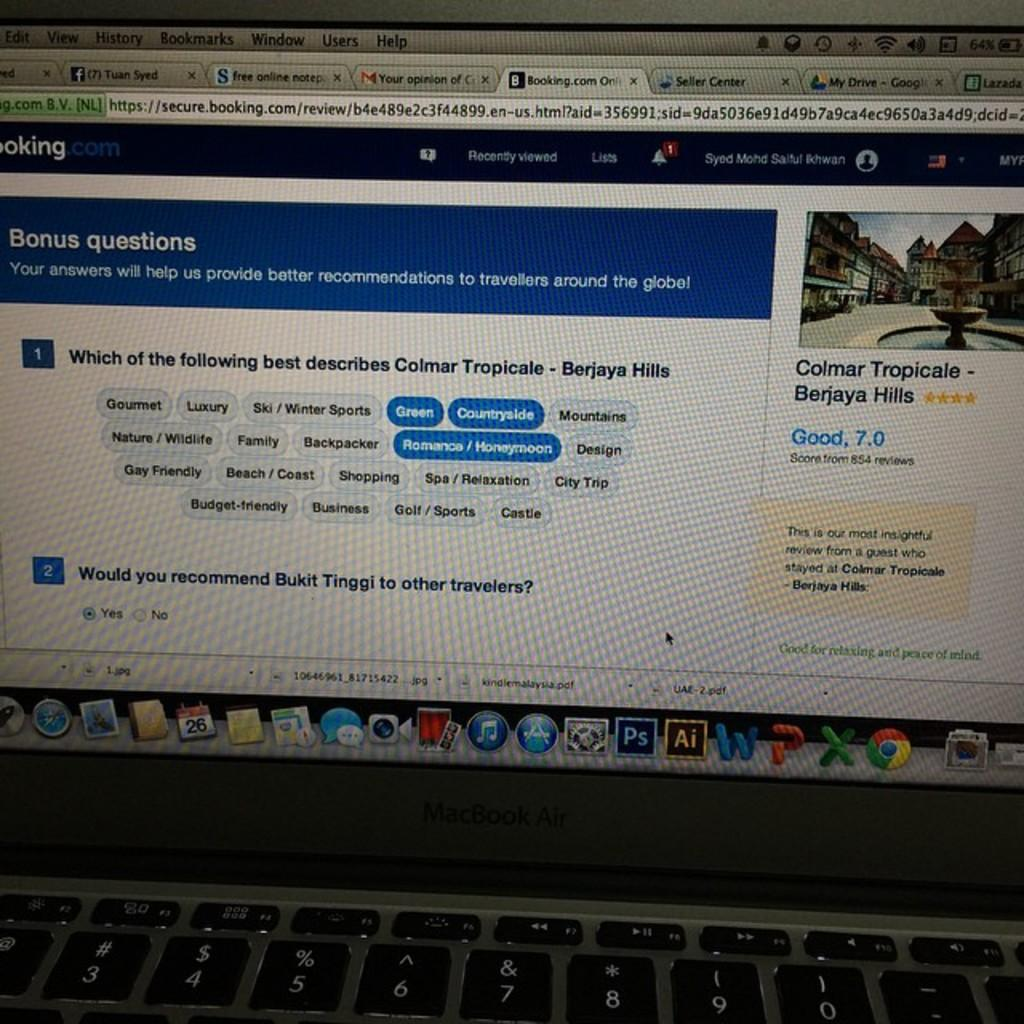<image>
Share a concise interpretation of the image provided. A computer screen from a MacBook Air laptop with a booking.com page displayed 